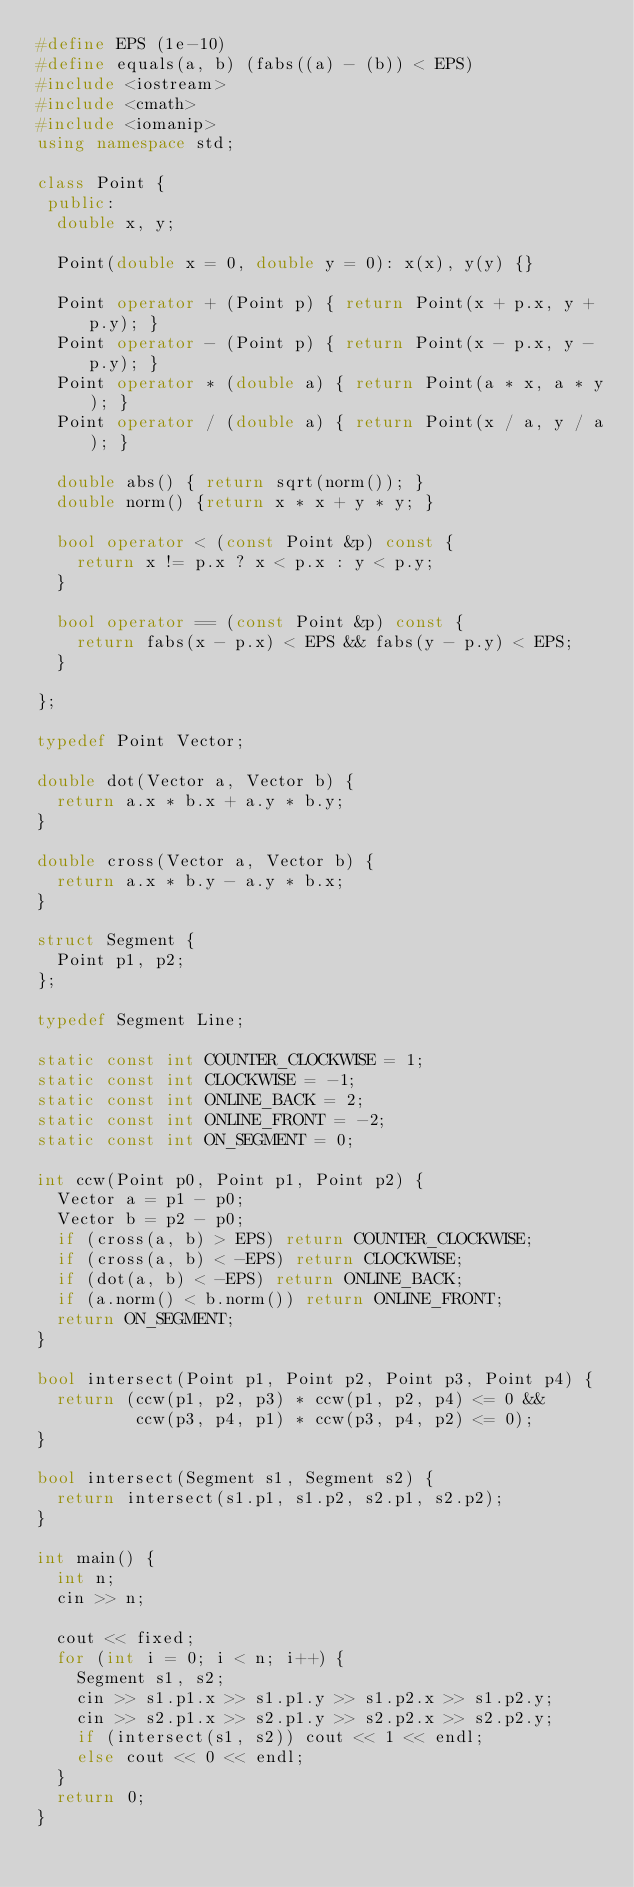Convert code to text. <code><loc_0><loc_0><loc_500><loc_500><_C++_>#define EPS (1e-10)
#define equals(a, b) (fabs((a) - (b)) < EPS)
#include <iostream>
#include <cmath>
#include <iomanip>
using namespace std;

class Point {
 public:
  double x, y;

  Point(double x = 0, double y = 0): x(x), y(y) {}

  Point operator + (Point p) { return Point(x + p.x, y + p.y); }
  Point operator - (Point p) { return Point(x - p.x, y - p.y); }
  Point operator * (double a) { return Point(a * x, a * y); }
  Point operator / (double a) { return Point(x / a, y / a); }

  double abs() { return sqrt(norm()); }
  double norm() {return x * x + y * y; }

  bool operator < (const Point &p) const {
    return x != p.x ? x < p.x : y < p.y;
  }

  bool operator == (const Point &p) const {
    return fabs(x - p.x) < EPS && fabs(y - p.y) < EPS;
  }

};

typedef Point Vector;

double dot(Vector a, Vector b) {
  return a.x * b.x + a.y * b.y;
}

double cross(Vector a, Vector b) {
  return a.x * b.y - a.y * b.x;
}

struct Segment {
  Point p1, p2;
};

typedef Segment Line;

static const int COUNTER_CLOCKWISE = 1;
static const int CLOCKWISE = -1;
static const int ONLINE_BACK = 2;
static const int ONLINE_FRONT = -2;
static const int ON_SEGMENT = 0;

int ccw(Point p0, Point p1, Point p2) {
  Vector a = p1 - p0;
  Vector b = p2 - p0;
  if (cross(a, b) > EPS) return COUNTER_CLOCKWISE;
  if (cross(a, b) < -EPS) return CLOCKWISE;
  if (dot(a, b) < -EPS) return ONLINE_BACK;
  if (a.norm() < b.norm()) return ONLINE_FRONT;
  return ON_SEGMENT;
}

bool intersect(Point p1, Point p2, Point p3, Point p4) {
  return (ccw(p1, p2, p3) * ccw(p1, p2, p4) <= 0 &&
          ccw(p3, p4, p1) * ccw(p3, p4, p2) <= 0);
}

bool intersect(Segment s1, Segment s2) {
  return intersect(s1.p1, s1.p2, s2.p1, s2.p2);
}

int main() {
  int n;
  cin >> n;

  cout << fixed;
  for (int i = 0; i < n; i++) {
    Segment s1, s2;
    cin >> s1.p1.x >> s1.p1.y >> s1.p2.x >> s1.p2.y;
    cin >> s2.p1.x >> s2.p1.y >> s2.p2.x >> s2.p2.y;
    if (intersect(s1, s2)) cout << 1 << endl;
    else cout << 0 << endl;
  }
  return 0;
}

</code> 